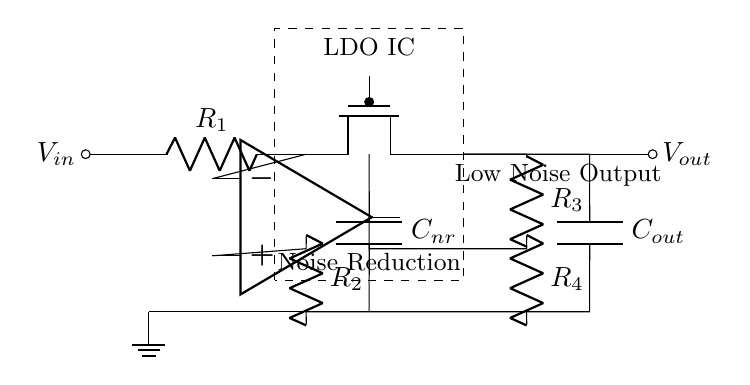What is the purpose of capacitor Cnr? Capacitor Cnr is a noise reduction capacitor that helps minimize voltage fluctuations and smoothes out noise in the audio output. This is critical in audio applications to ensure a clean sound signal is delivered.
Answer: Noise reduction What components are used in the feedback loop? The feedback loop consists of resistors R3 and R4, which work together to stabilize the output voltage by creating a feedback voltage that influences the error amplifier in the LDO.
Answer: R3 and R4 How many resistors are in the circuit? There are four resistors in this circuit, which include R1, R2, R3, and R4. Each resistor has a unique role, with R1 acting as an input resistor and R2 being part of the feedback mechanism, while R3 and R4 help regulate voltage output.
Answer: Four What type of transistor is used in this LDO regulator? This LDO circuit employs a PMOS transistor, shown in the diagram as Tpmos, which is integral for regulating the output voltage while maintaining a low dropout voltage.
Answer: PMOS What type of output does this circuit provide? This circuit provides a low noise output, specifically designed for audio signal processing, which ensures the integrity and quality of the audio signal is preserved.
Answer: Low noise output What is the value of the voltage at Vin if the circuit is powered? The voltage at Vin is not explicitly stated in the diagram, but it is typically the power supply voltage applied to the circuit, usually indicated in a practical implementation.
Answer: Supply voltage (not defined) 